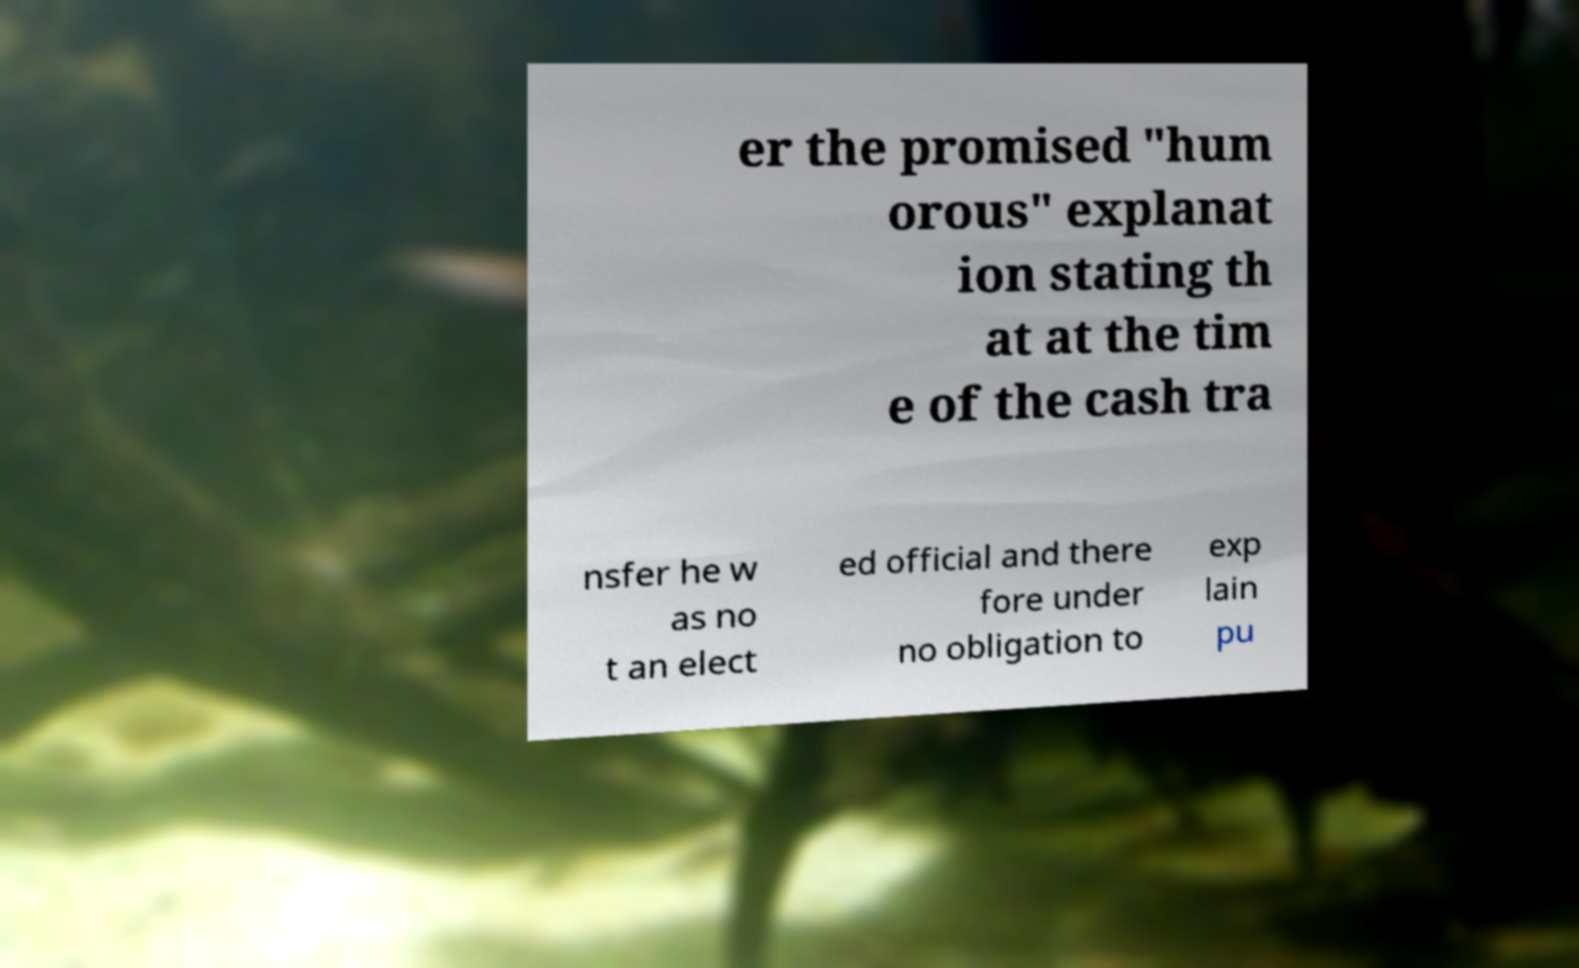Could you extract and type out the text from this image? er the promised "hum orous" explanat ion stating th at at the tim e of the cash tra nsfer he w as no t an elect ed official and there fore under no obligation to exp lain pu 